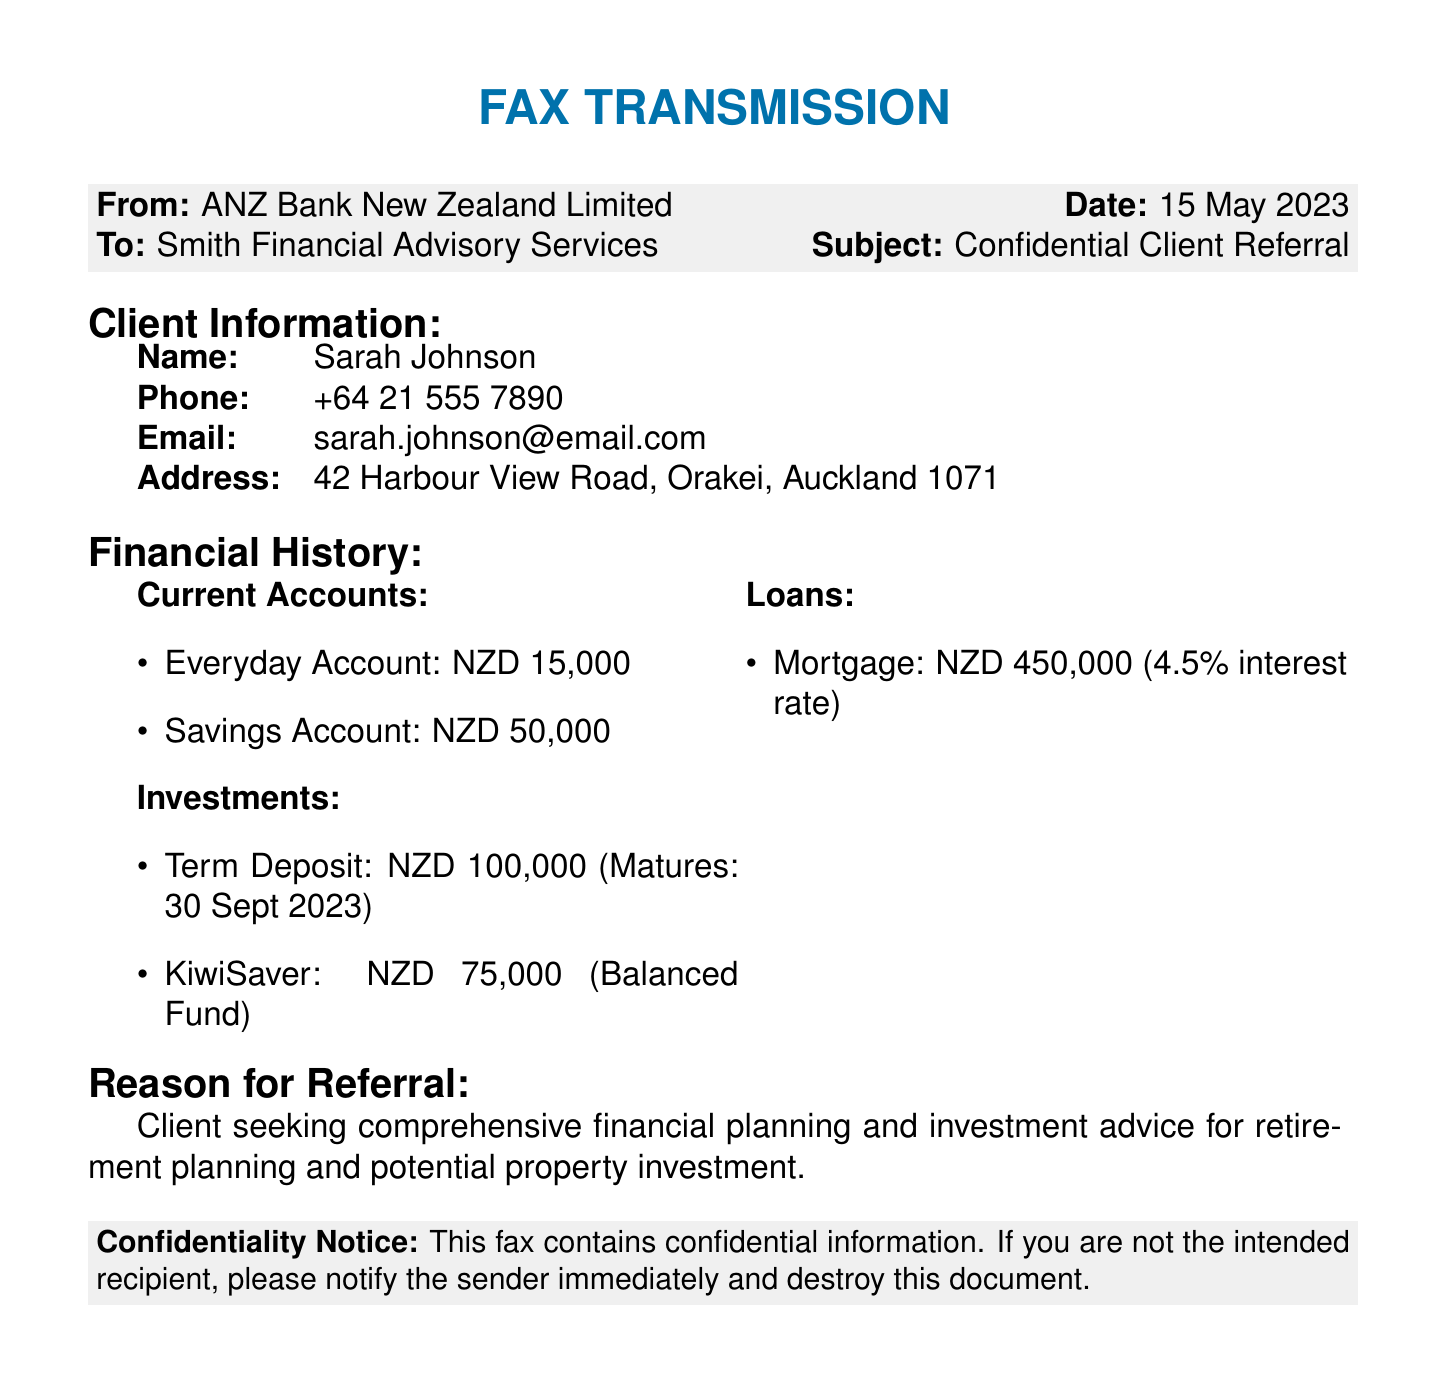What is the name of the client? The name of the client is specified in the client information section of the document.
Answer: Sarah Johnson What is the client's email address? The client's email address is provided in the client information section.
Answer: sarah.johnson@email.com How much is in the client's savings account? The amount in the savings account is listed under the current accounts in the financial history section.
Answer: NZD 50,000 What is the interest rate of the client’s mortgage? The interest rate for the mortgage is detailed in the loans section of the financial history.
Answer: 4.5% When does the term deposit mature? The maturity date of the term deposit is noted in the investments section of the financial history.
Answer: 30 Sept 2023 What financial advice is the client seeking? The reason for referral indicates what type of financial advice the client is looking for.
Answer: Comprehensive financial planning and investment advice What is the value of the client's KiwiSaver? The value of the KiwiSaver is provided in the investments section of the financial history.
Answer: NZD 75,000 Who is the sender of the fax? The sender of the fax is identified at the top of the document.
Answer: ANZ Bank New Zealand Limited What is the subject of the fax? The subject is stated clearly in the fax header.
Answer: Confidential Client Referral 